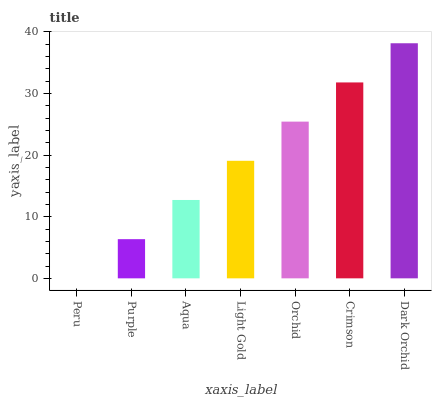Is Peru the minimum?
Answer yes or no. Yes. Is Dark Orchid the maximum?
Answer yes or no. Yes. Is Purple the minimum?
Answer yes or no. No. Is Purple the maximum?
Answer yes or no. No. Is Purple greater than Peru?
Answer yes or no. Yes. Is Peru less than Purple?
Answer yes or no. Yes. Is Peru greater than Purple?
Answer yes or no. No. Is Purple less than Peru?
Answer yes or no. No. Is Light Gold the high median?
Answer yes or no. Yes. Is Light Gold the low median?
Answer yes or no. Yes. Is Orchid the high median?
Answer yes or no. No. Is Crimson the low median?
Answer yes or no. No. 